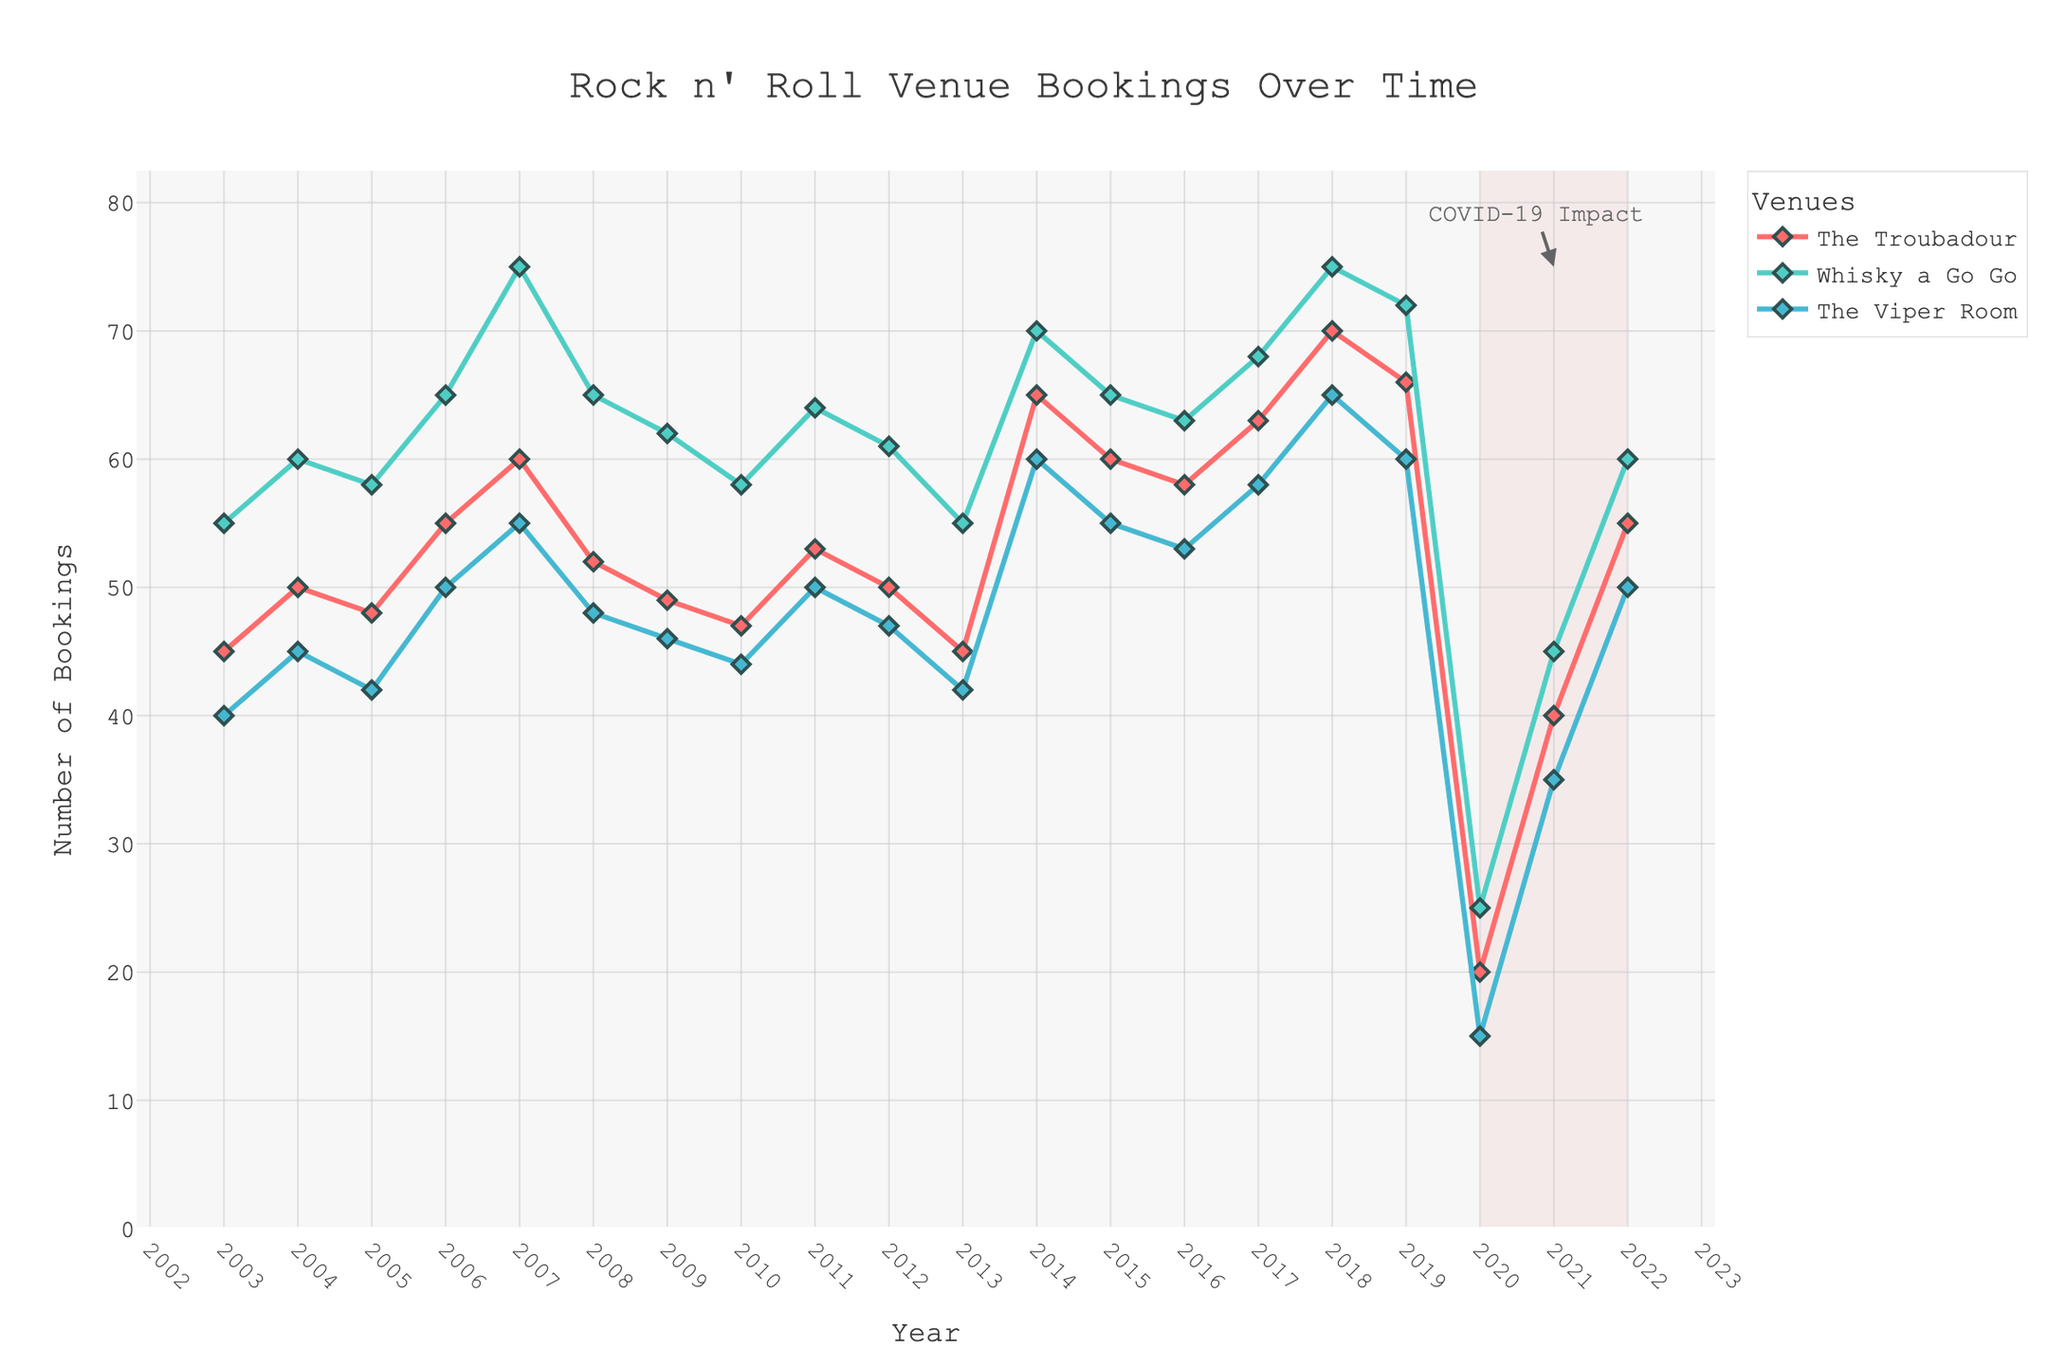What's the title of the graph? The title is typically found at the top center of the graph. This graph's title reads: "Rock n' Roll Venue Bookings Over Time"
Answer: Rock n' Roll Venue Bookings Over Time Which venue had the most bookings in 2018? Look at the year 2018 on the x-axis and compare the y-axis values for each venue. The graph shows that Whisky a Go Go had the most bookings that year.
Answer: Whisky a Go Go What was the impact of COVID-19 on bookings? There is a shaded area from 2020 to 2022 with an annotation pointing out "COVID-19 Impact." During this period, all venues experienced a sharp drop in bookings, with the lowest point occurring in 2020.
Answer: A sharp drop in bookings How did The Troubadour's bookings change from 2019 to 2020? Locate the years 2019 and 2020 on the x-axis for The Troubadour's line. The bookings dropped significantly from 66 in 2019 to 20 in 2020.
Answer: Dropped from 66 to 20 Which year had the lowest bookings for The Viper Room? For The Viper Room, find the year with the lowest y-axis value. The graph indicates that 2020 had the lowest bookings at 15.
Answer: 2020 Between The Troubadour and Whisky a Go Go, which venue had a steeper decline in bookings in 2020? Compare the drop in bookings from 2019 to 2020 for both venues. The Troubadour dropped from 66 to 20, a 46-booking decrease, while Whisky a Go Go dropped from 72 to 25, a 47-booking decrease.
Answer: Whisky a Go Go What is the average number of bookings for The Viper Room from 2003 to 2022? Sum the bookings for The Viper Room across the years and divide by the number of years (20). The sum is 875, so the average is 875 / 20 = 43.75.
Answer: 43.75 Which venue consistently had the highest number of bookings over the twenty years? Compare each venue's bookings over the entire time period. Whisky a Go Go generally shows higher bookings compared to the other venues.
Answer: Whisky a Go Go Were there any years when all three venues had lower-than-average bookings? Calculate or estimate the average for each venue, then look for years where all bookings fall below their averages. The year 2020 is clear due to its significantly low values for all venues, owing to COVID-19.
Answer: 2020 What trend is seen in booking numbers for The Viper Room from 2017 to 2019? Examine the graph lines from 2017 to 2019. The bookings rise from 58 in 2017 to 65 in 2018 and then slightly drop to 60 in 2019.
Answer: A rise, followed by a slight drop 